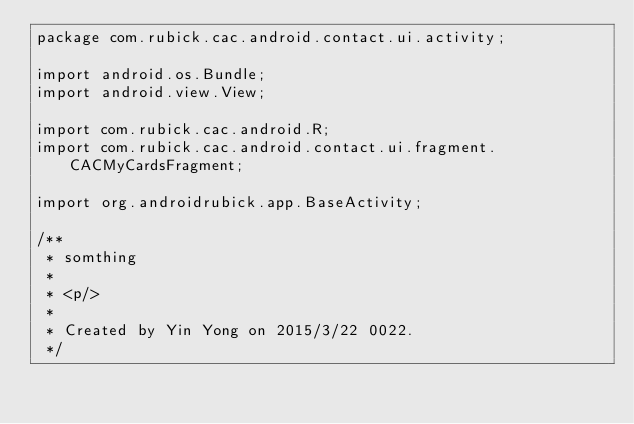<code> <loc_0><loc_0><loc_500><loc_500><_Java_>package com.rubick.cac.android.contact.ui.activity;

import android.os.Bundle;
import android.view.View;

import com.rubick.cac.android.R;
import com.rubick.cac.android.contact.ui.fragment.CACMyCardsFragment;

import org.androidrubick.app.BaseActivity;

/**
 * somthing
 *
 * <p/>
 *
 * Created by Yin Yong on 2015/3/22 0022.
 */</code> 